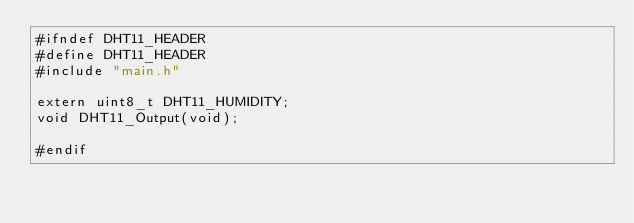Convert code to text. <code><loc_0><loc_0><loc_500><loc_500><_C_>#ifndef DHT11_HEADER
#define DHT11_HEADER
#include "main.h"

extern uint8_t DHT11_HUMIDITY;
void DHT11_Output(void);

#endif
</code> 